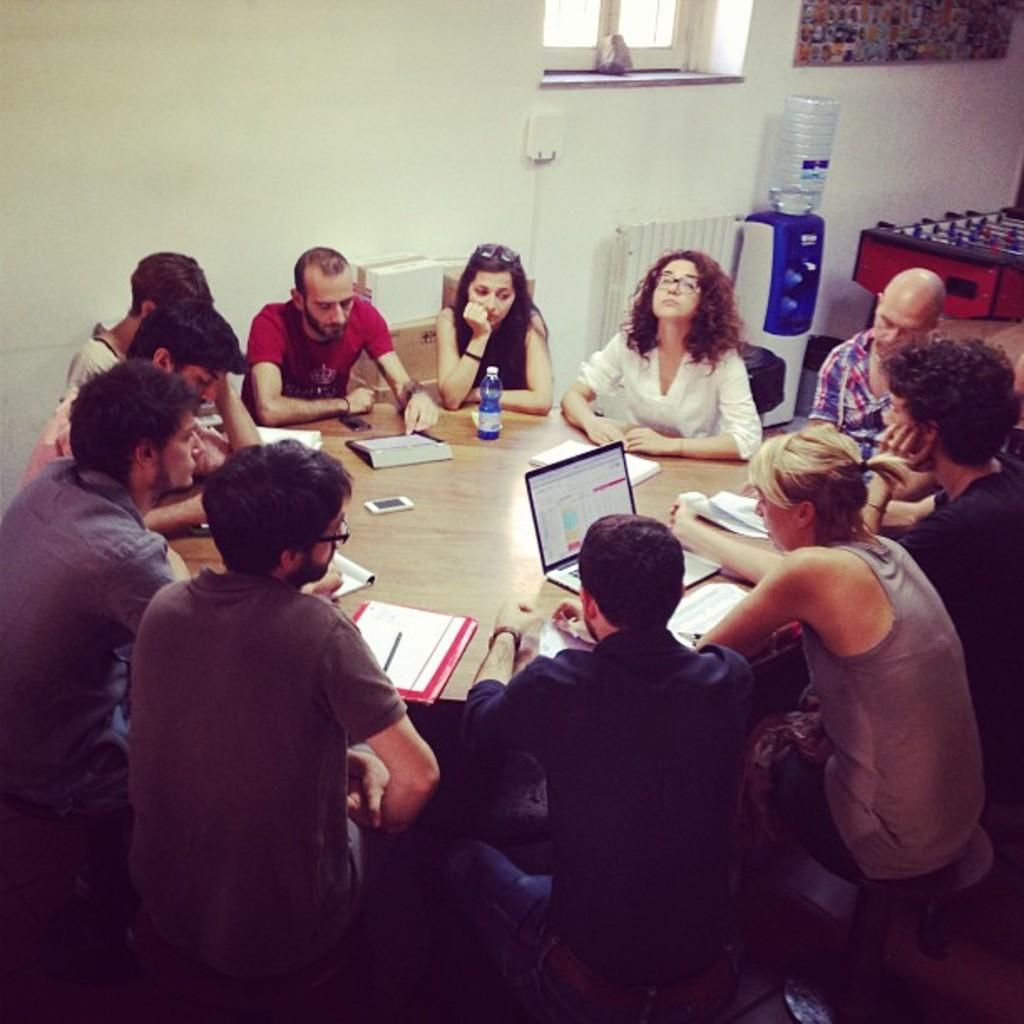How many people are in the image? There are many people in the image. What are the people doing in the image? The people are sitting at a round table. What can be seen in the background of the image? There is a water filter and a glass window in the background of the image. How many fish are swimming in the water filter in the image? There are no fish present in the image, and the water filter is not a body of water where fish would be found. 